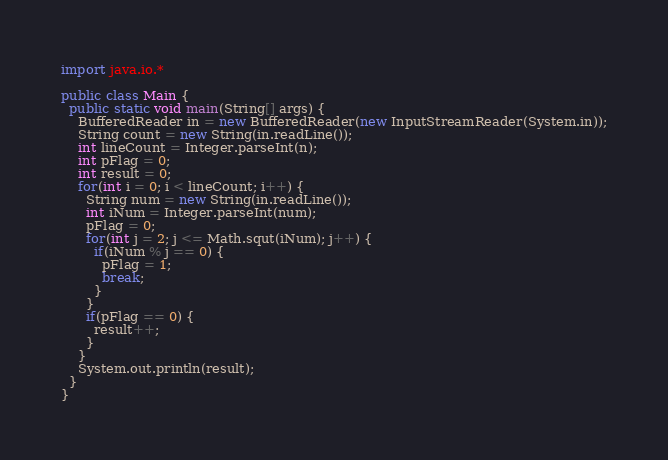Convert code to text. <code><loc_0><loc_0><loc_500><loc_500><_Java_>import java.io.*

public class Main {
  public static void main(String[] args) {
    BufferedReader in = new BufferedReader(new InputStreamReader(System.in));
    String count = new String(in.readLine());
    int lineCount = Integer.parseInt(n);
    int pFlag = 0;
    int result = 0;
    for(int i = 0; i < lineCount; i++) {
      String num = new String(in.readLine());
      int iNum = Integer.parseInt(num);
      pFlag = 0;
      for(int j = 2; j <= Math.squt(iNum); j++) {
        if(iNum % j == 0) {
          pFlag = 1;
          break;
        }
      }
      if(pFlag == 0) {
        result++;
      }
    }
    System.out.println(result);
  }
}</code> 